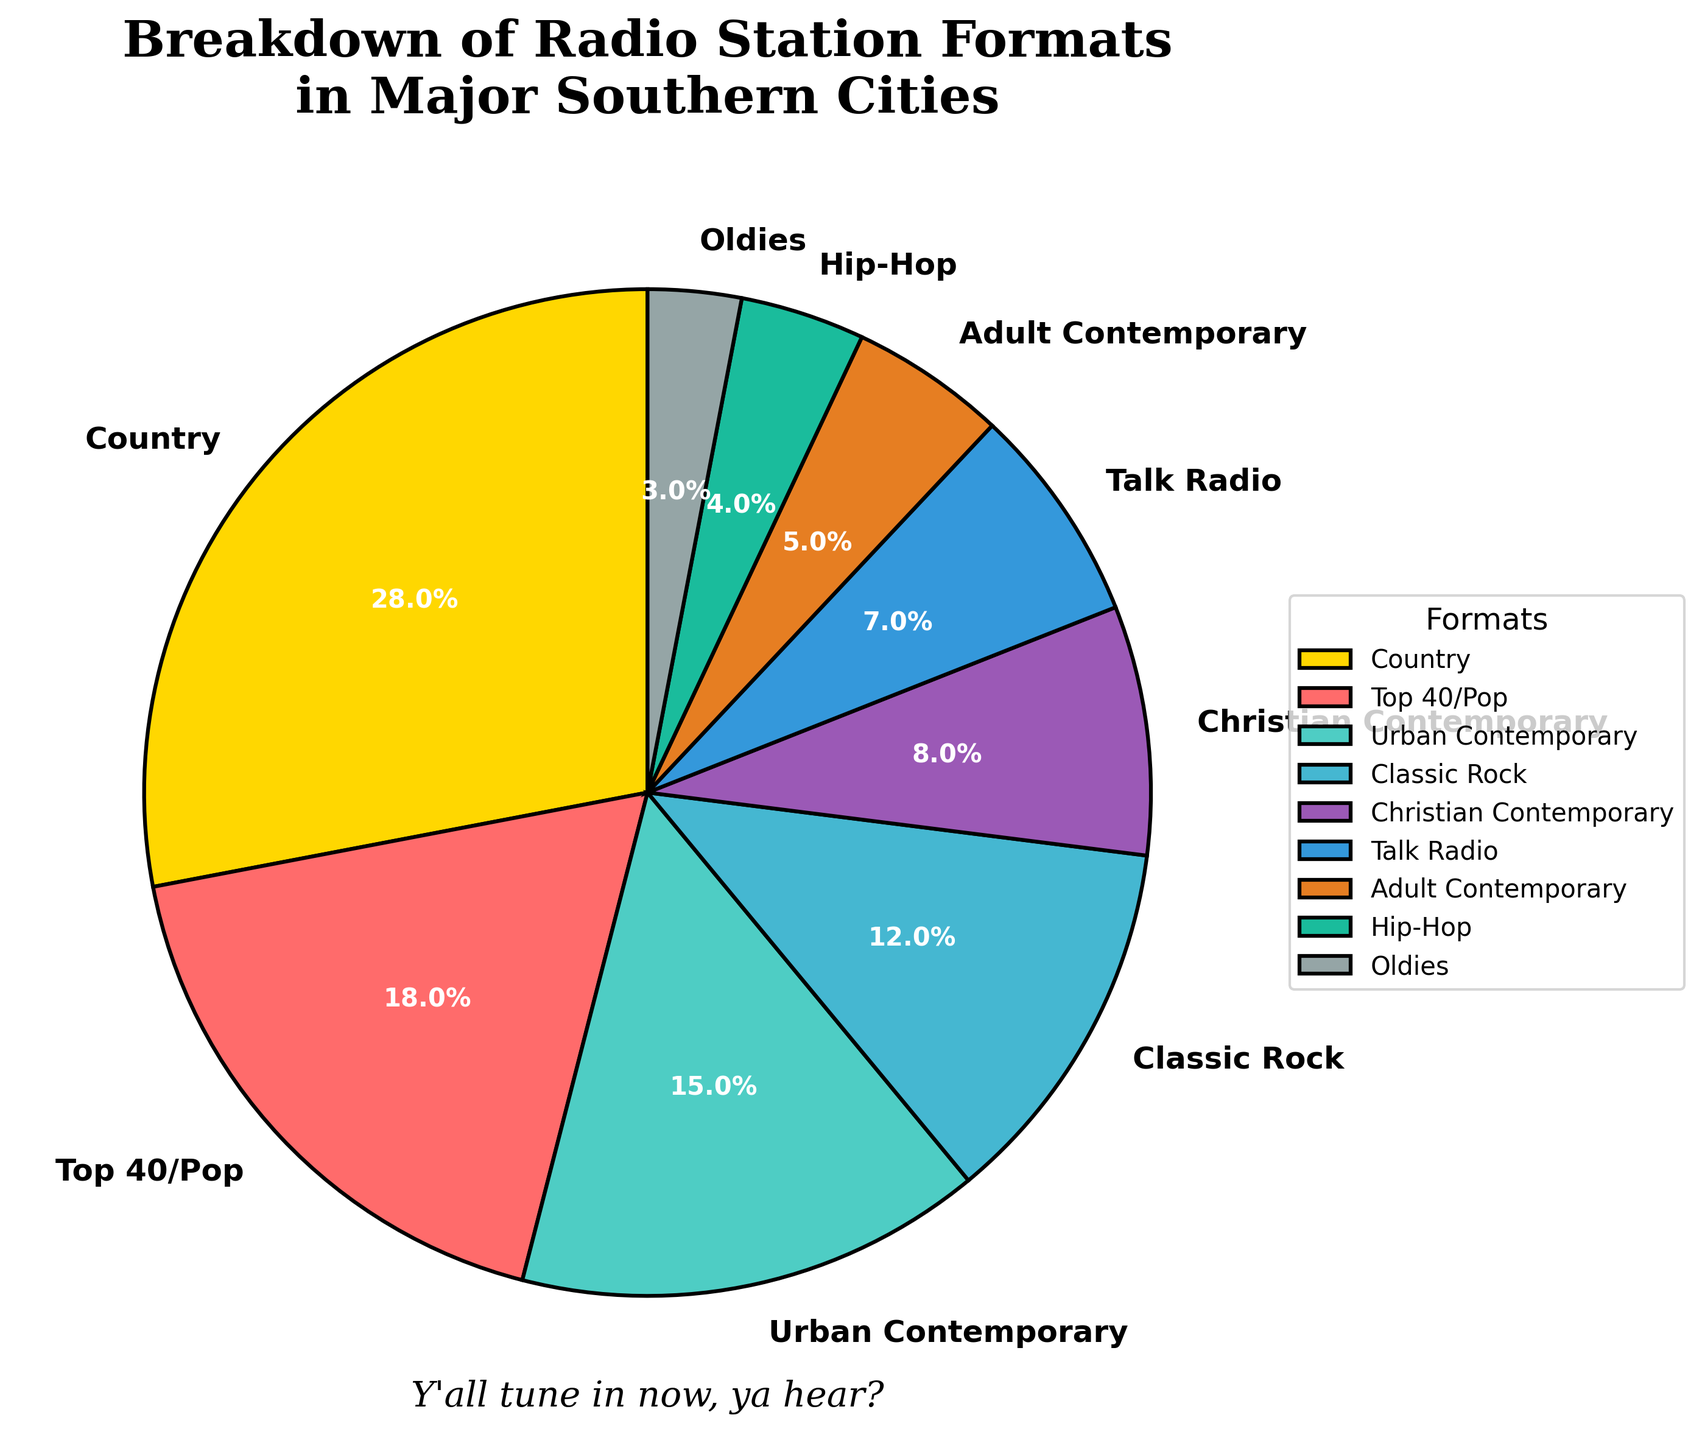What's the most common radio station format in major Southern cities? The format with the highest percentage on the pie chart is the most common one. The segment labeled "Country" has the highest percentage at 28%.
Answer: Country How much more popular is Top 40/Pop compared to Adult Contemporary? The percentage for Top 40/Pop is 18%, and for Adult Contemporary, it is 5%. The difference is 18% - 5% = 13%.
Answer: 13% Which format is more popular: Hip-Hop or Talk Radio? Comparing the percentages on the pie chart, Hip-Hop is 4%, and Talk Radio is 7%. Therefore, Talk Radio is more popular.
Answer: Talk Radio If you combine the percentages of Classic Rock and Christian Contemporary, what would the total be? Classic Rock has 12% and Christian Contemporary has 8%. Adding these together: 12% + 8% = 20%.
Answer: 20% Which three formats combined make up the largest portion of the chart? The three largest percentages are Country (28%), Top 40/Pop (18%), and Urban Contemporary (15%). Adding these: 28% + 18% + 15% = 61%.
Answer: Country, Top 40/Pop, Urban Contemporary What's the exact difference in percentage between the least and most popular formats? The percentage for the most popular format (Country) is 28%, and for the least popular format (Oldies), it is 3%. The difference is 28% - 3% = 25%.
Answer: 25% Which format has a light blue color? Looking at the colors used in the pie chart, the format with a light blue segment is Classic Rock.
Answer: Classic Rock How much more popular are Urban Contemporary and Christian Contemporary combined compared to Talk Radio? Urban Contemporary is 15% and Christian Contemporary is 8%. Their combined percentage is 15% + 8% = 23%. Talk Radio is 7%. The difference is 23% - 7% = 16%.
Answer: 16% Find the sum of the percentages for the formats that have percentages less than 10%. The relevant formats are Christian Contemporary (8%), Talk Radio (7%), Adult Contemporary (5%), Hip-Hop (4%), and Oldies (3%). Adding these: 8% + 7% + 5% + 4% + 3% = 27%.
Answer: 27% What format is represented by green in the pie chart? The pie chart segment that is green represents Hip-Hop.
Answer: Hip-Hop 